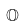Convert formula to latex. <formula><loc_0><loc_0><loc_500><loc_500>\mathbb { O }</formula> 